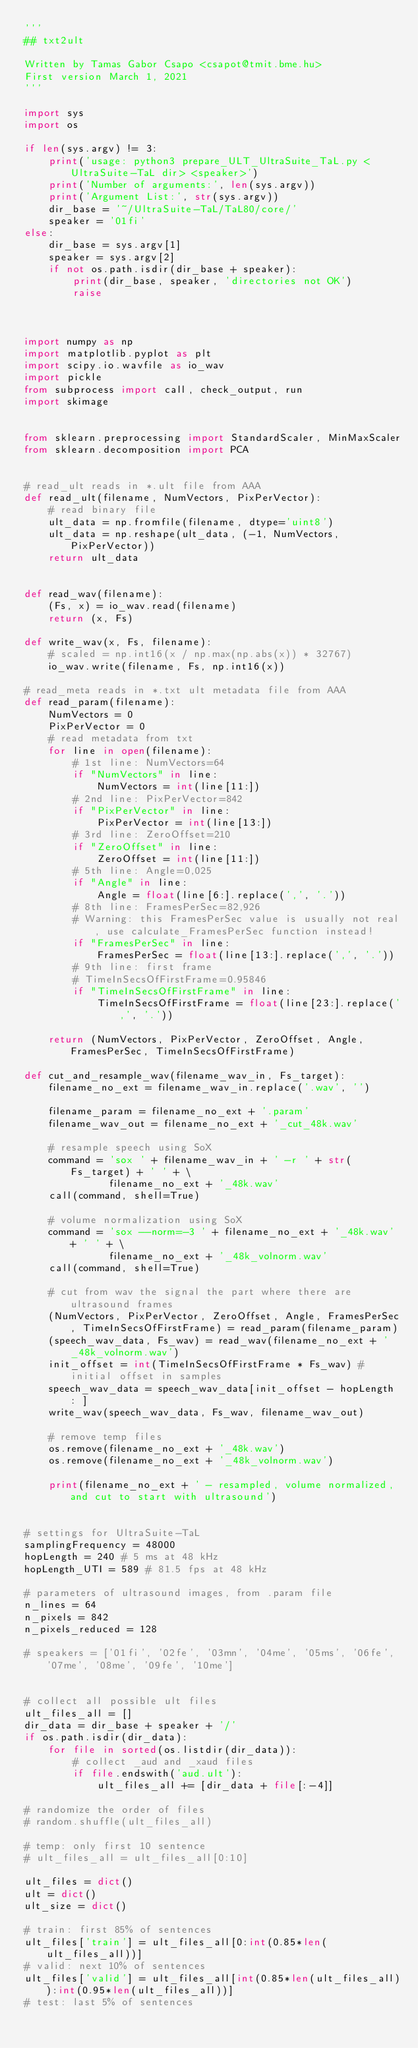Convert code to text. <code><loc_0><loc_0><loc_500><loc_500><_Python_>'''
## txt2ult

Written by Tamas Gabor Csapo <csapot@tmit.bme.hu>
First version March 1, 2021
'''

import sys
import os

if len(sys.argv) != 3:
    print('usage: python3 prepare_ULT_UltraSuite_TaL.py <UltraSuite-TaL dir> <speaker>')
    print('Number of arguments:', len(sys.argv))
    print('Argument List:', str(sys.argv))
    dir_base = '~/UltraSuite-TaL/TaL80/core/'
    speaker = '01fi'
else:
    dir_base = sys.argv[1]
    speaker = sys.argv[2]
    if not os.path.isdir(dir_base + speaker):
        print(dir_base, speaker, 'directories not OK')
        raise



import numpy as np
import matplotlib.pyplot as plt
import scipy.io.wavfile as io_wav
import pickle
from subprocess import call, check_output, run
import skimage


from sklearn.preprocessing import StandardScaler, MinMaxScaler
from sklearn.decomposition import PCA


# read_ult reads in *.ult file from AAA
def read_ult(filename, NumVectors, PixPerVector):
    # read binary file
    ult_data = np.fromfile(filename, dtype='uint8')
    ult_data = np.reshape(ult_data, (-1, NumVectors, PixPerVector))
    return ult_data


def read_wav(filename):
    (Fs, x) = io_wav.read(filename)
    return (x, Fs)

def write_wav(x, Fs, filename):
    # scaled = np.int16(x / np.max(np.abs(x)) * 32767)
    io_wav.write(filename, Fs, np.int16(x))

# read_meta reads in *.txt ult metadata file from AAA
def read_param(filename):    
    NumVectors = 0
    PixPerVector = 0
    # read metadata from txt
    for line in open(filename):
        # 1st line: NumVectors=64
        if "NumVectors" in line:
            NumVectors = int(line[11:])
        # 2nd line: PixPerVector=842
        if "PixPerVector" in line:
            PixPerVector = int(line[13:])
        # 3rd line: ZeroOffset=210
        if "ZeroOffset" in line:
            ZeroOffset = int(line[11:])
        # 5th line: Angle=0,025
        if "Angle" in line:
            Angle = float(line[6:].replace(',', '.'))
        # 8th line: FramesPerSec=82,926
        # Warning: this FramesPerSec value is usually not real, use calculate_FramesPerSec function instead!
        if "FramesPerSec" in line:
            FramesPerSec = float(line[13:].replace(',', '.'))
        # 9th line: first frame
        # TimeInSecsOfFirstFrame=0.95846
        if "TimeInSecsOfFirstFrame" in line:
            TimeInSecsOfFirstFrame = float(line[23:].replace(',', '.'))
    
    return (NumVectors, PixPerVector, ZeroOffset, Angle, FramesPerSec, TimeInSecsOfFirstFrame)

def cut_and_resample_wav(filename_wav_in, Fs_target):
    filename_no_ext = filename_wav_in.replace('.wav', '')
    
    filename_param = filename_no_ext + '.param'
    filename_wav_out = filename_no_ext + '_cut_48k.wav'
    
    # resample speech using SoX
    command = 'sox ' + filename_wav_in + ' -r ' + str(Fs_target) + ' ' + \
              filename_no_ext + '_48k.wav'
    call(command, shell=True)
    
    # volume normalization using SoX
    command = 'sox --norm=-3 ' + filename_no_ext + '_48k.wav' + ' ' + \
              filename_no_ext + '_48k_volnorm.wav'
    call(command, shell=True)
    
    # cut from wav the signal the part where there are ultrasound frames
    (NumVectors, PixPerVector, ZeroOffset, Angle, FramesPerSec, TimeInSecsOfFirstFrame) = read_param(filename_param)
    (speech_wav_data, Fs_wav) = read_wav(filename_no_ext + '_48k_volnorm.wav')
    init_offset = int(TimeInSecsOfFirstFrame * Fs_wav) # initial offset in samples
    speech_wav_data = speech_wav_data[init_offset - hopLength : ]
    write_wav(speech_wav_data, Fs_wav, filename_wav_out)
    
    # remove temp files
    os.remove(filename_no_ext + '_48k.wav')
    os.remove(filename_no_ext + '_48k_volnorm.wav')
    
    print(filename_no_ext + ' - resampled, volume normalized, and cut to start with ultrasound')
    

# settings for UltraSuite-TaL
samplingFrequency = 48000
hopLength = 240 # 5 ms at 48 kHz
hopLength_UTI = 589 # 81.5 fps at 48 kHz

# parameters of ultrasound images, from .param file
n_lines = 64
n_pixels = 842
n_pixels_reduced = 128

# speakers = ['01fi', '02fe', '03mn', '04me', '05ms', '06fe', '07me', '08me', '09fe', '10me']

    
# collect all possible ult files
ult_files_all = []
dir_data = dir_base + speaker + '/'
if os.path.isdir(dir_data):
    for file in sorted(os.listdir(dir_data)):
        # collect _aud and _xaud files
        if file.endswith('aud.ult'):
            ult_files_all += [dir_data + file[:-4]]

# randomize the order of files
# random.shuffle(ult_files_all)

# temp: only first 10 sentence
# ult_files_all = ult_files_all[0:10]

ult_files = dict()
ult = dict()
ult_size = dict()

# train: first 85% of sentences
ult_files['train'] = ult_files_all[0:int(0.85*len(ult_files_all))]
# valid: next 10% of sentences
ult_files['valid'] = ult_files_all[int(0.85*len(ult_files_all)):int(0.95*len(ult_files_all))]
# test: last 5% of sentences</code> 